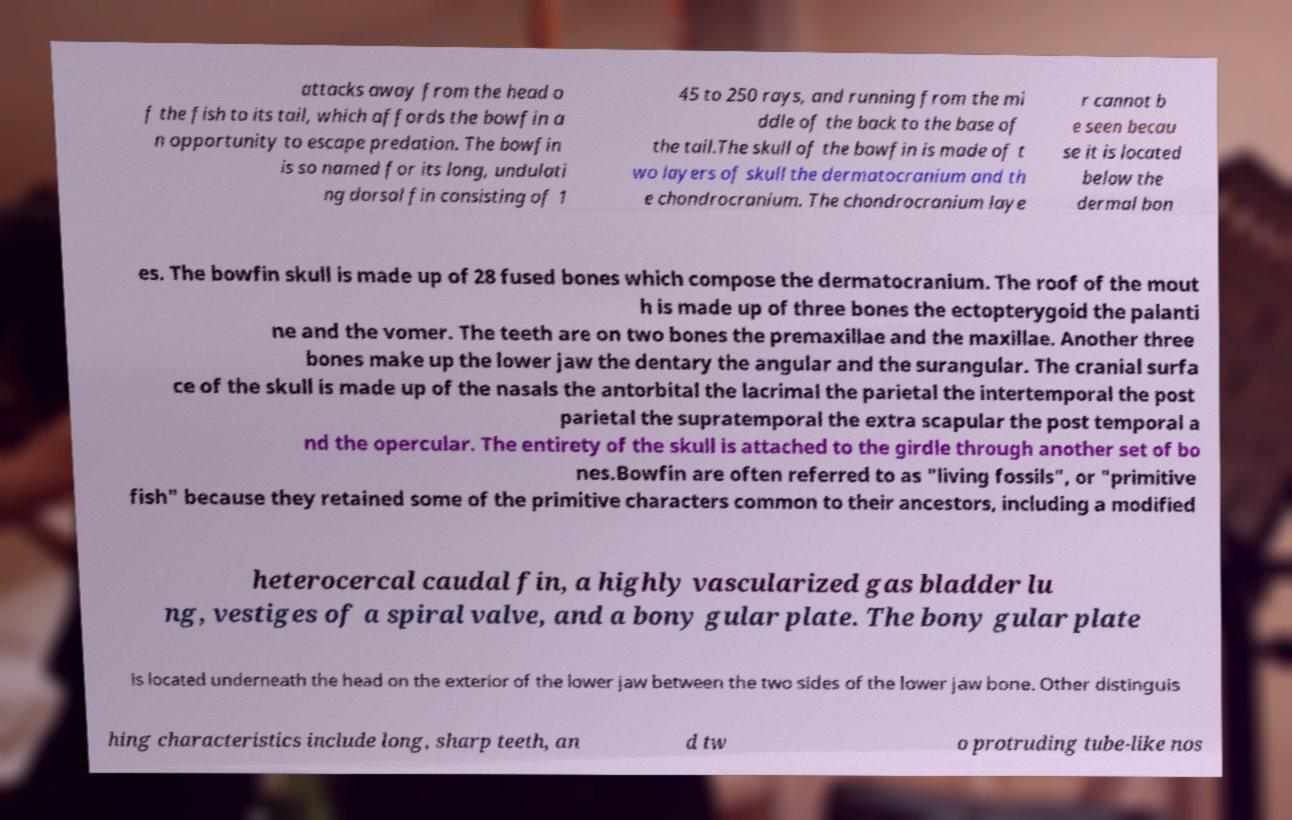What messages or text are displayed in this image? I need them in a readable, typed format. attacks away from the head o f the fish to its tail, which affords the bowfin a n opportunity to escape predation. The bowfin is so named for its long, undulati ng dorsal fin consisting of 1 45 to 250 rays, and running from the mi ddle of the back to the base of the tail.The skull of the bowfin is made of t wo layers of skull the dermatocranium and th e chondrocranium. The chondrocranium laye r cannot b e seen becau se it is located below the dermal bon es. The bowfin skull is made up of 28 fused bones which compose the dermatocranium. The roof of the mout h is made up of three bones the ectopterygoid the palanti ne and the vomer. The teeth are on two bones the premaxillae and the maxillae. Another three bones make up the lower jaw the dentary the angular and the surangular. The cranial surfa ce of the skull is made up of the nasals the antorbital the lacrimal the parietal the intertemporal the post parietal the supratemporal the extra scapular the post temporal a nd the opercular. The entirety of the skull is attached to the girdle through another set of bo nes.Bowfin are often referred to as "living fossils", or "primitive fish" because they retained some of the primitive characters common to their ancestors, including a modified heterocercal caudal fin, a highly vascularized gas bladder lu ng, vestiges of a spiral valve, and a bony gular plate. The bony gular plate is located underneath the head on the exterior of the lower jaw between the two sides of the lower jaw bone. Other distinguis hing characteristics include long, sharp teeth, an d tw o protruding tube-like nos 